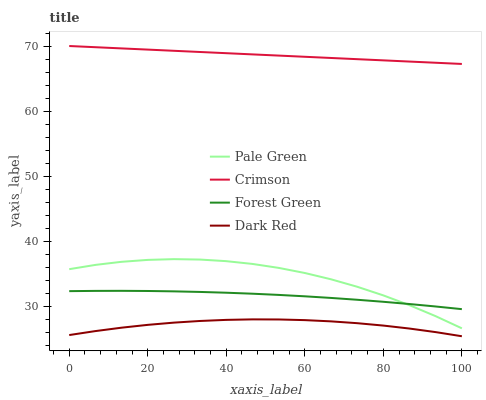Does Dark Red have the minimum area under the curve?
Answer yes or no. Yes. Does Crimson have the maximum area under the curve?
Answer yes or no. Yes. Does Forest Green have the minimum area under the curve?
Answer yes or no. No. Does Forest Green have the maximum area under the curve?
Answer yes or no. No. Is Crimson the smoothest?
Answer yes or no. Yes. Is Pale Green the roughest?
Answer yes or no. Yes. Is Dark Red the smoothest?
Answer yes or no. No. Is Dark Red the roughest?
Answer yes or no. No. Does Dark Red have the lowest value?
Answer yes or no. Yes. Does Forest Green have the lowest value?
Answer yes or no. No. Does Crimson have the highest value?
Answer yes or no. Yes. Does Forest Green have the highest value?
Answer yes or no. No. Is Dark Red less than Forest Green?
Answer yes or no. Yes. Is Crimson greater than Forest Green?
Answer yes or no. Yes. Does Pale Green intersect Forest Green?
Answer yes or no. Yes. Is Pale Green less than Forest Green?
Answer yes or no. No. Is Pale Green greater than Forest Green?
Answer yes or no. No. Does Dark Red intersect Forest Green?
Answer yes or no. No. 